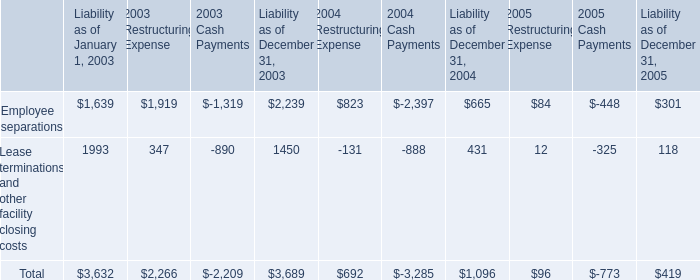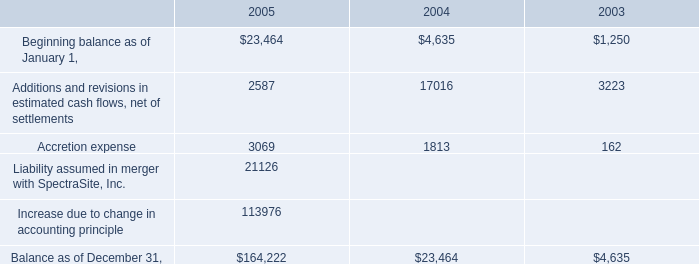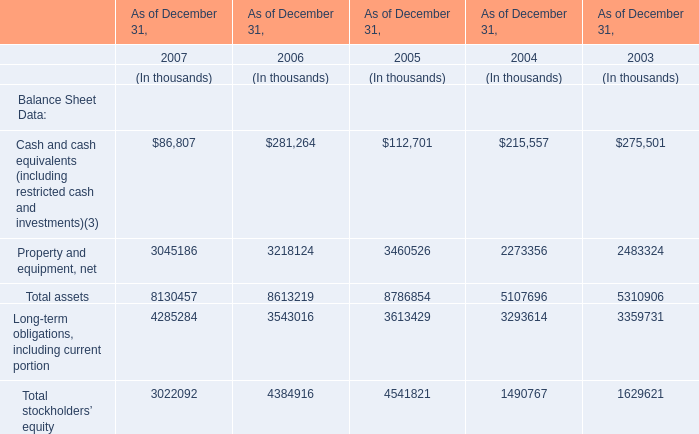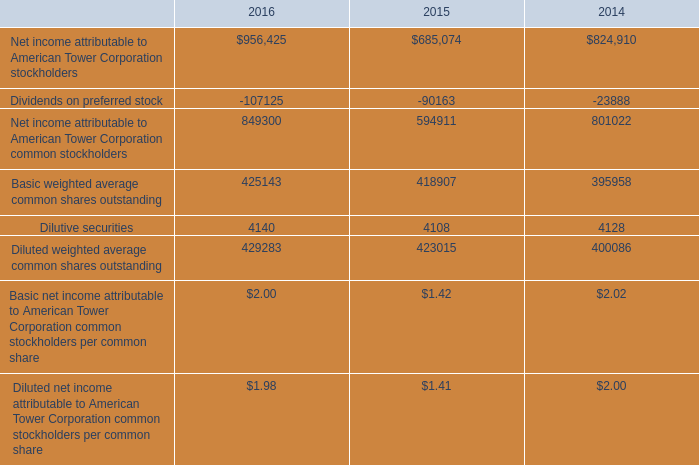Which year is Total assets the most? (in thousands) 
Answer: 8786854. 